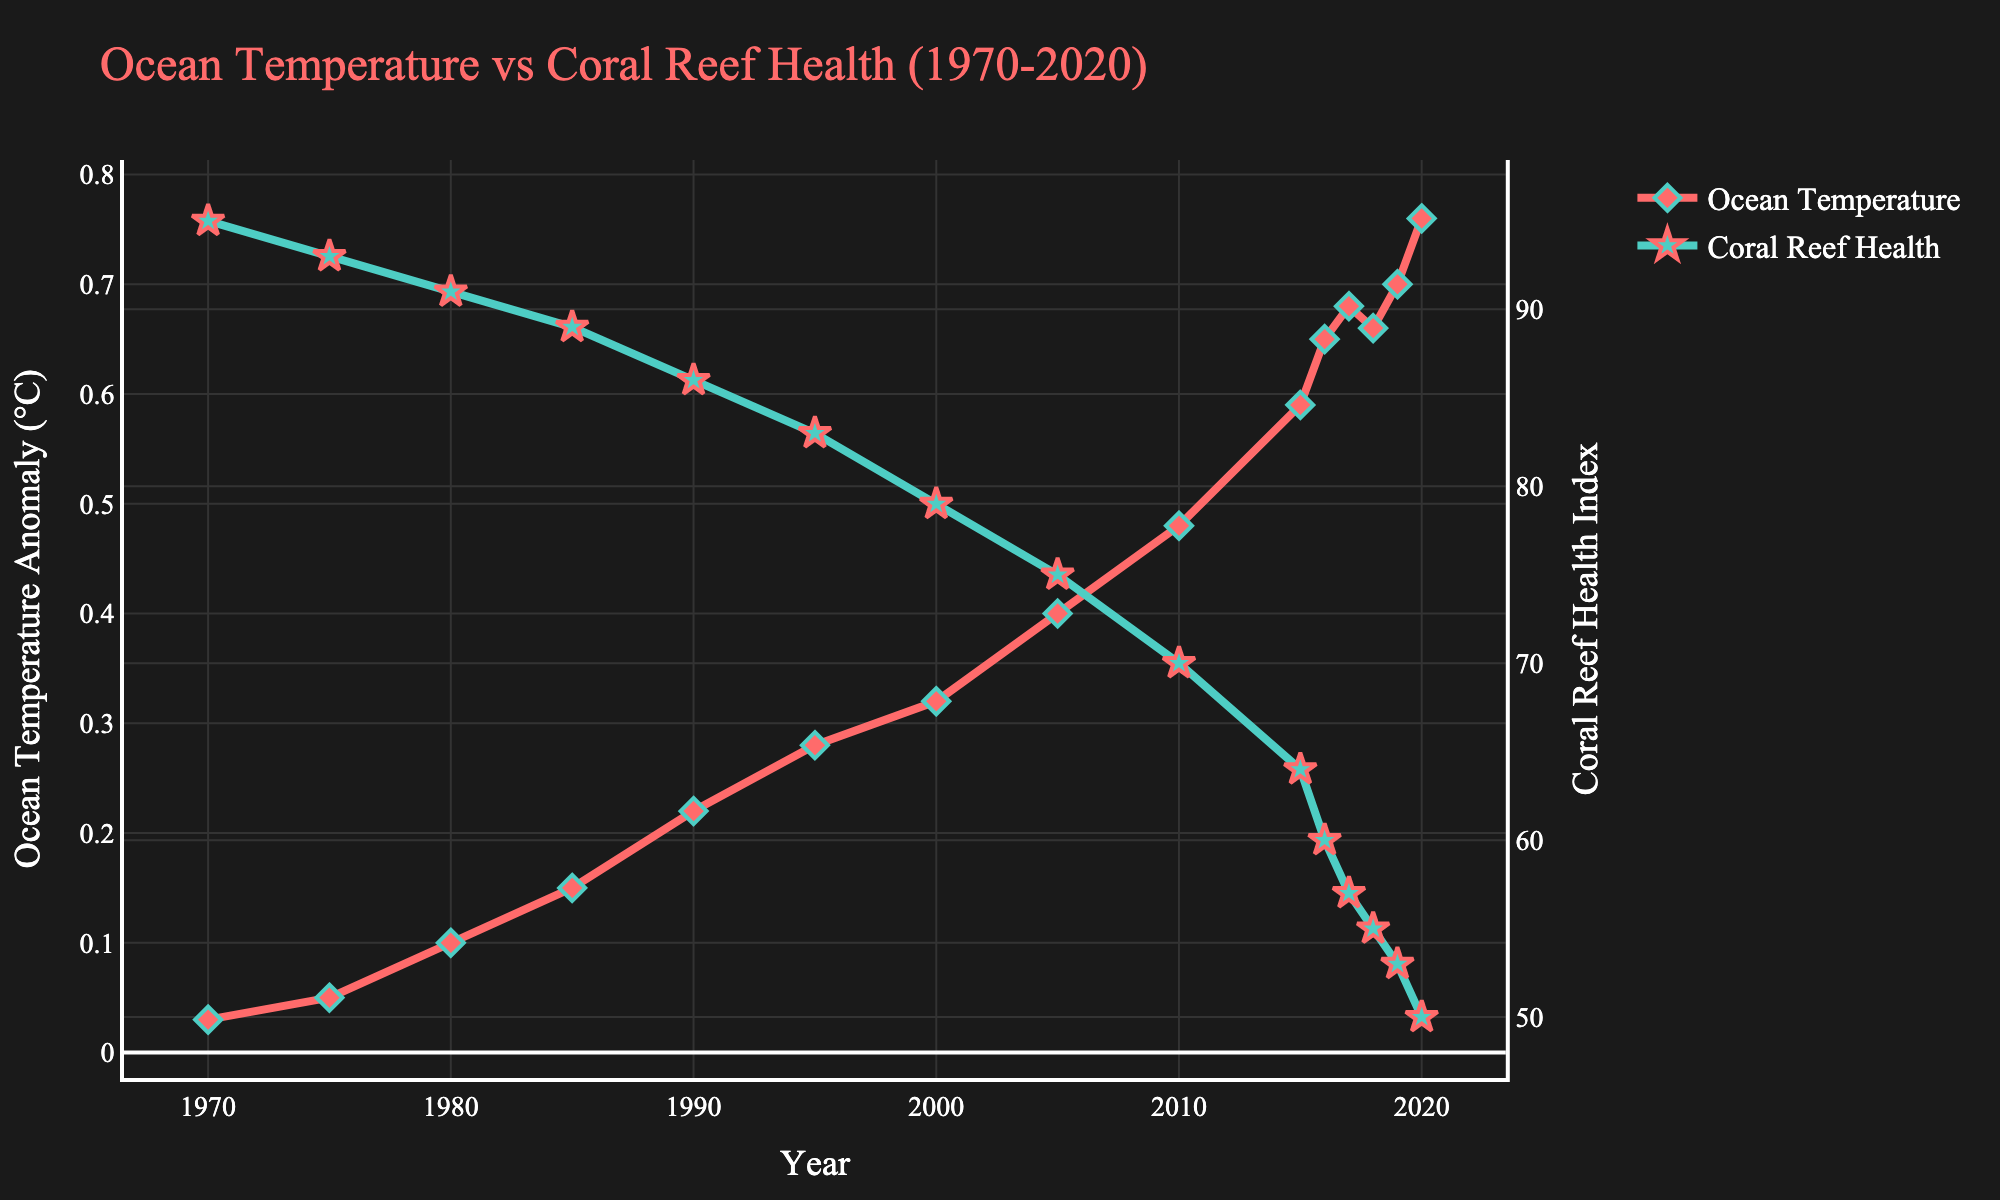What's the average Global Ocean Temperature Anomaly over the past 50 years? Sum the anomalies from each year and divide by the total number of years: (0.03+0.05+0.10+0.15+0.22+0.28+0.32+0.40+0.48+0.59+0.65+0.68+0.66+0.70+0.76) / 15 = 6.27 / 15
Answer: 0.418 In which year did the Coral Reef Health Index drop below 80 for the first time? Find the first year where the Coral Reef Health Index is less than 80, which occurs in the year 2000
Answer: 2000 How much has the Global Ocean Temperature Anomaly increased from 1970 to 2020? Subtract the anomaly in 1970 from the anomaly in 2020: 0.76 - 0.03 = 0.73
Answer: 0.73 Which year had the steepest increase in Global Ocean Temperature Anomaly? Calculate the year-on-year difference and find the largest: (0.65 - 0.59 = 0.06 in 2015-2016)
Answer: 2015-2016 What is the difference in Coral Reef Health Index between 1970 and 2000? Subtract the index in 2000 from the index in 1970: 95 - 79 = 16
Answer: 16 During which years did the Coral Reef Health Index decrease the most? Calculate the year-on-year differences and find the largest drop: (64 - 60 = 4 in 2015-2016)
Answer: 2015-2016 What is the overall trend in the Coral Reef Health Index from 1970 to 2020? Observe the line plot of Coral Reef Health Index which consistently decreases over the years.
Answer: Decreasing Which visual elements differentiate the Ocean Temperature and Coral Reef Health indices on the plot? Ocean Temperature line uses red color and diamond markers, Coral Reef Health uses green color and star markers.
Answer: Color and marker shapes Compare the Coral Reef Health Index in 2010 and 2019. Find the values from the graph: 70 in 2010 and 53 in 2019. The comparison shows a reduction.
Answer: Lower in 2019 What was the Global Ocean Temperature Anomaly in 1990, and how did it affect the Coral Reef Health Index? The anomaly in 1990 is 0.22°C; compare it with the corresponding Coral Reef Health Index value of 86, showing a gradual decline.
Answer: 0.22°C, decline in health 